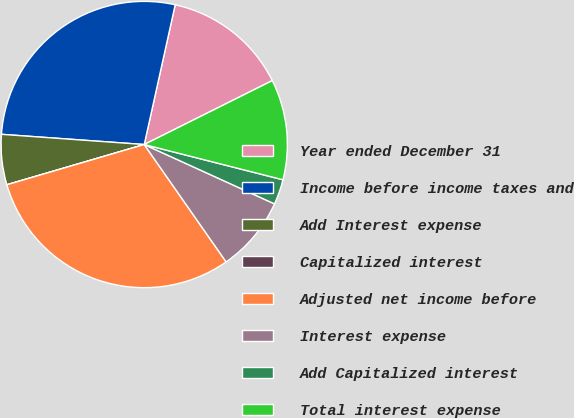Convert chart to OTSL. <chart><loc_0><loc_0><loc_500><loc_500><pie_chart><fcel>Year ended December 31<fcel>Income before income taxes and<fcel>Add Interest expense<fcel>Capitalized interest<fcel>Adjusted net income before<fcel>Interest expense<fcel>Add Capitalized interest<fcel>Total interest expense<nl><fcel>14.16%<fcel>27.33%<fcel>5.67%<fcel>0.0%<fcel>30.16%<fcel>8.5%<fcel>2.84%<fcel>11.33%<nl></chart> 